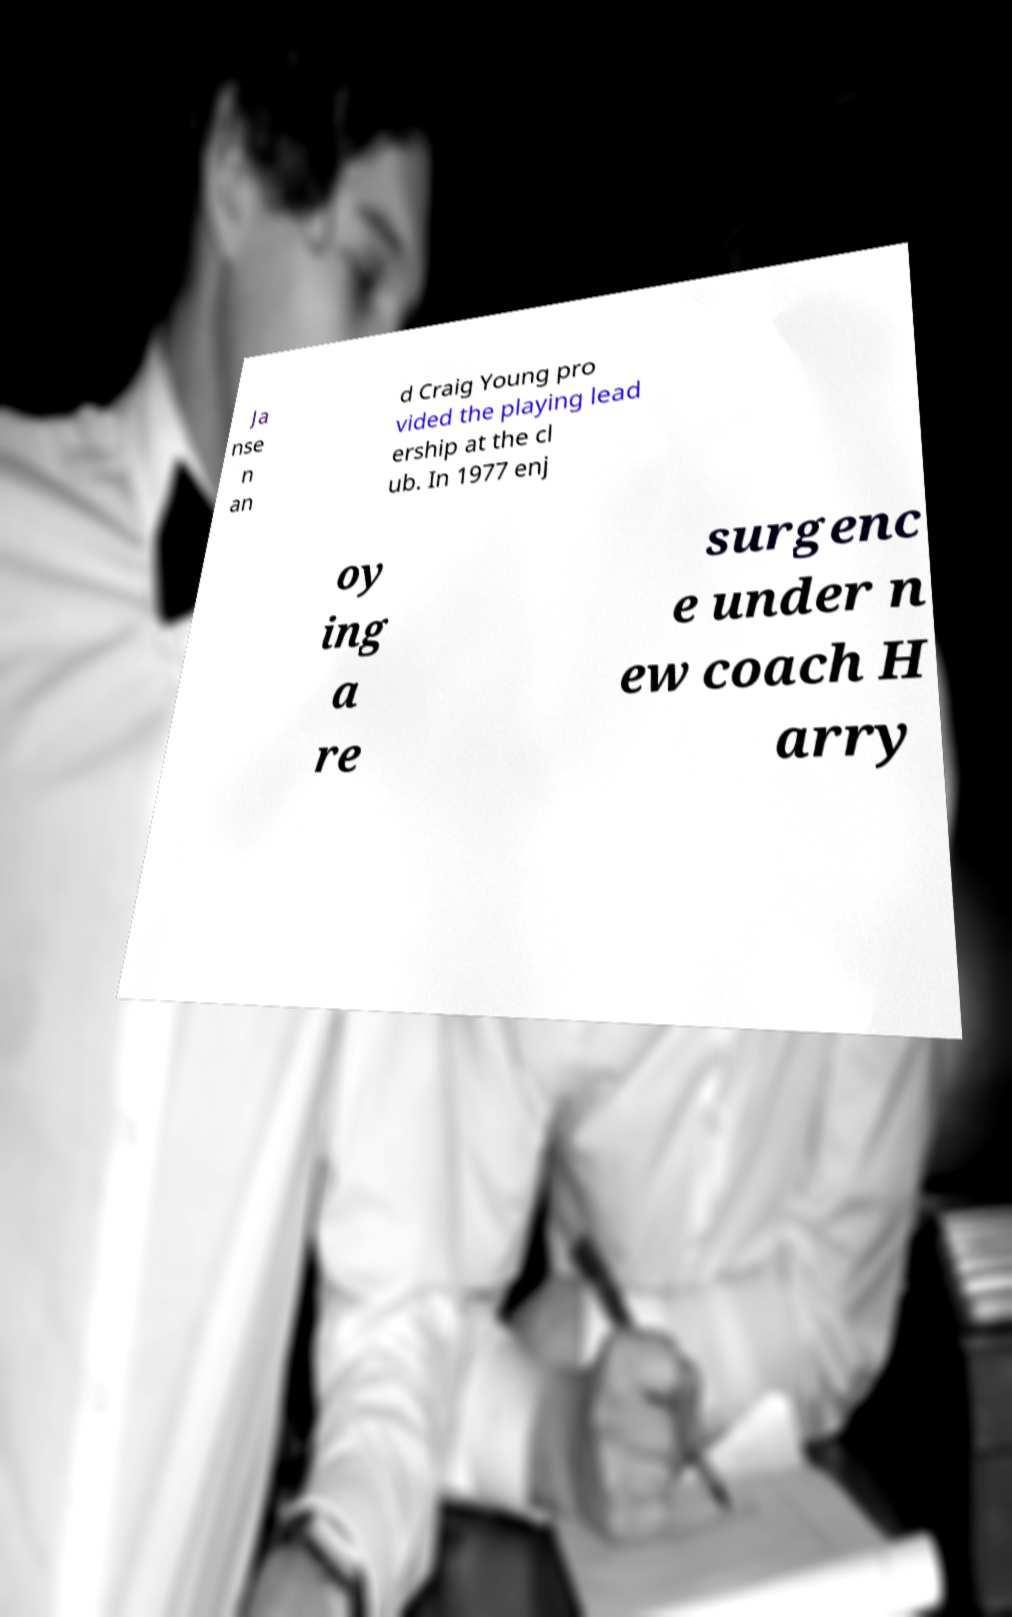Can you read and provide the text displayed in the image?This photo seems to have some interesting text. Can you extract and type it out for me? Ja nse n an d Craig Young pro vided the playing lead ership at the cl ub. In 1977 enj oy ing a re surgenc e under n ew coach H arry 